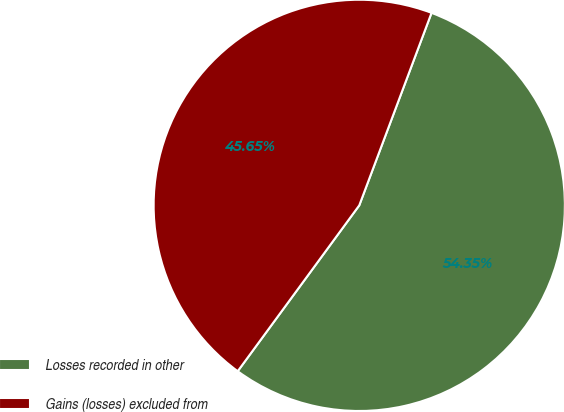Convert chart. <chart><loc_0><loc_0><loc_500><loc_500><pie_chart><fcel>Losses recorded in other<fcel>Gains (losses) excluded from<nl><fcel>54.35%<fcel>45.65%<nl></chart> 